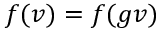<formula> <loc_0><loc_0><loc_500><loc_500>f ( v ) = f ( g v )</formula> 